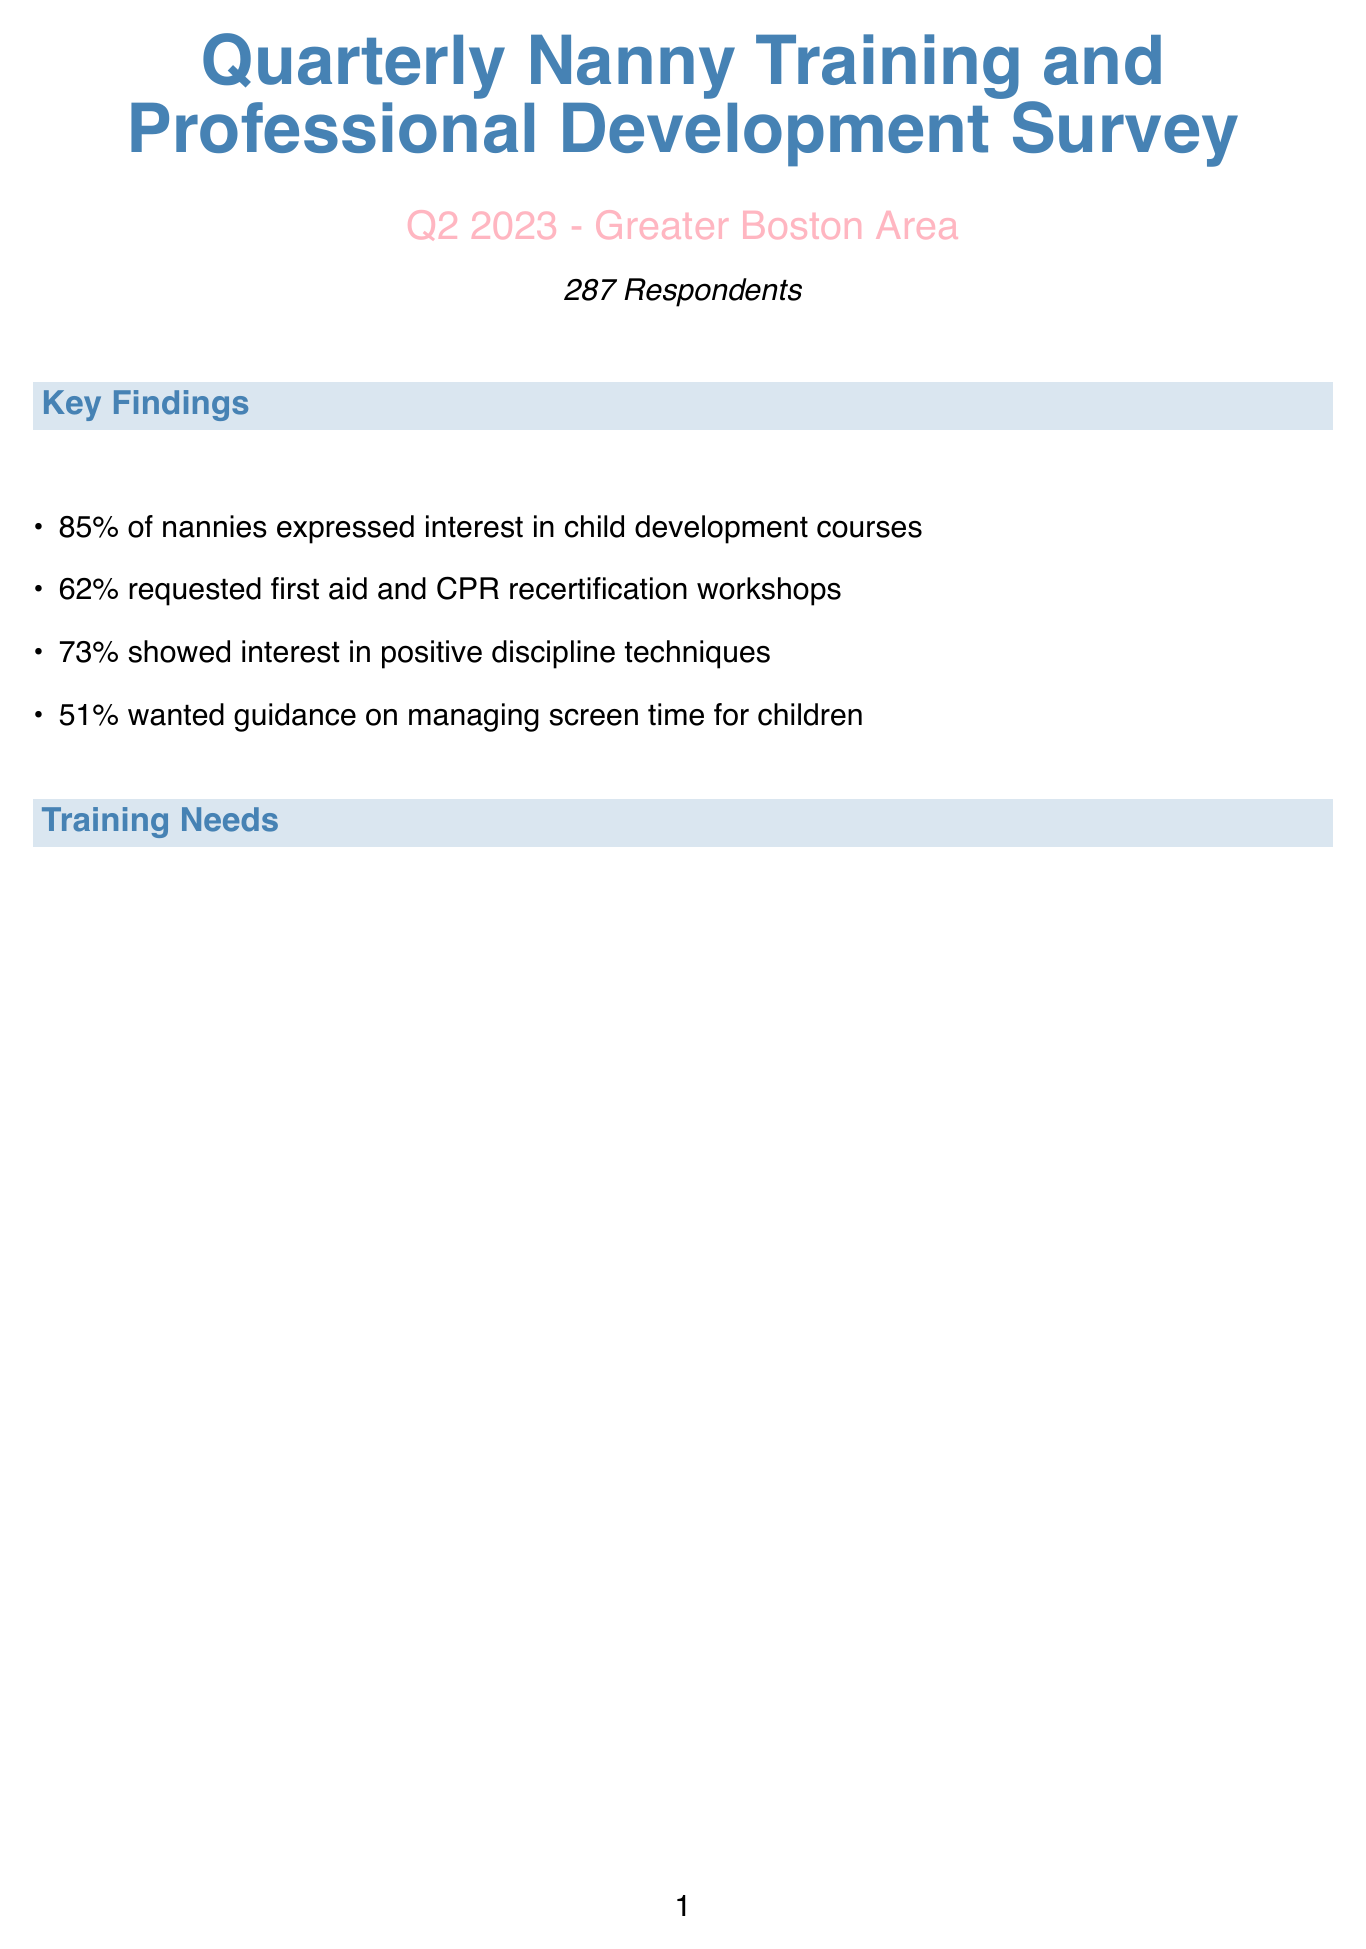What is the total number of survey respondents? The total number of survey respondents is mentioned in the document as 287.
Answer: 287 What percentage of nannies are interested in child development courses? The document states that 85% of nannies expressed interest in child development courses.
Answer: 85% What topic had the lowest percentage of interest among professional development interests? The lowest percentage of interest in professional development topics is for special needs care, which is 47%.
Answer: Special Needs Care Which organization is recommended for a safety certification program? The document suggests partnering with the American Red Cross for the safety certification program.
Answer: American Red Cross What specific topic is included under Technology and Media training needs? The document lists age-appropriate media content as a specific topic under Technology and Media training needs.
Answer: Age-appropriate media content Which two potential partners are recommended for the Child Development Workshop Series? The document recommends Boston Children's Hospital and Wheelock College of Education & Human Development as potential partners.
Answer: Boston Children's Hospital, Wheelock College of Education & Human Development What percentage of nannies expressed interest in time management and organization? The document indicates that 55% of nannies are interested in time management and organization.
Answer: 55% How many main categories of training needs are identified in the survey? The document outlines four main categories of training needs identified in the survey.
Answer: Four 